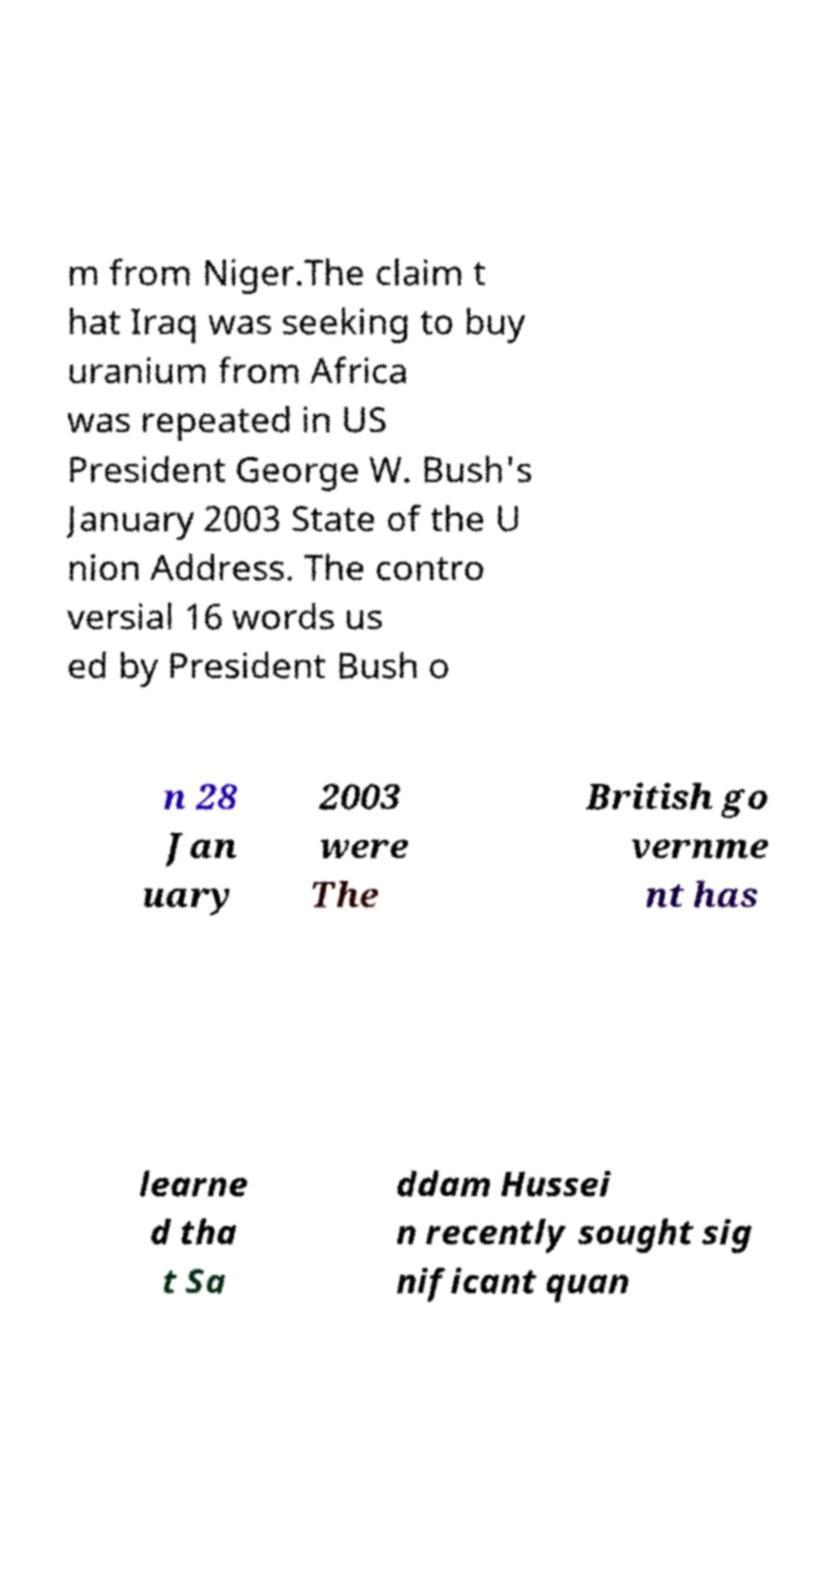Can you accurately transcribe the text from the provided image for me? m from Niger.The claim t hat Iraq was seeking to buy uranium from Africa was repeated in US President George W. Bush's January 2003 State of the U nion Address. The contro versial 16 words us ed by President Bush o n 28 Jan uary 2003 were The British go vernme nt has learne d tha t Sa ddam Hussei n recently sought sig nificant quan 